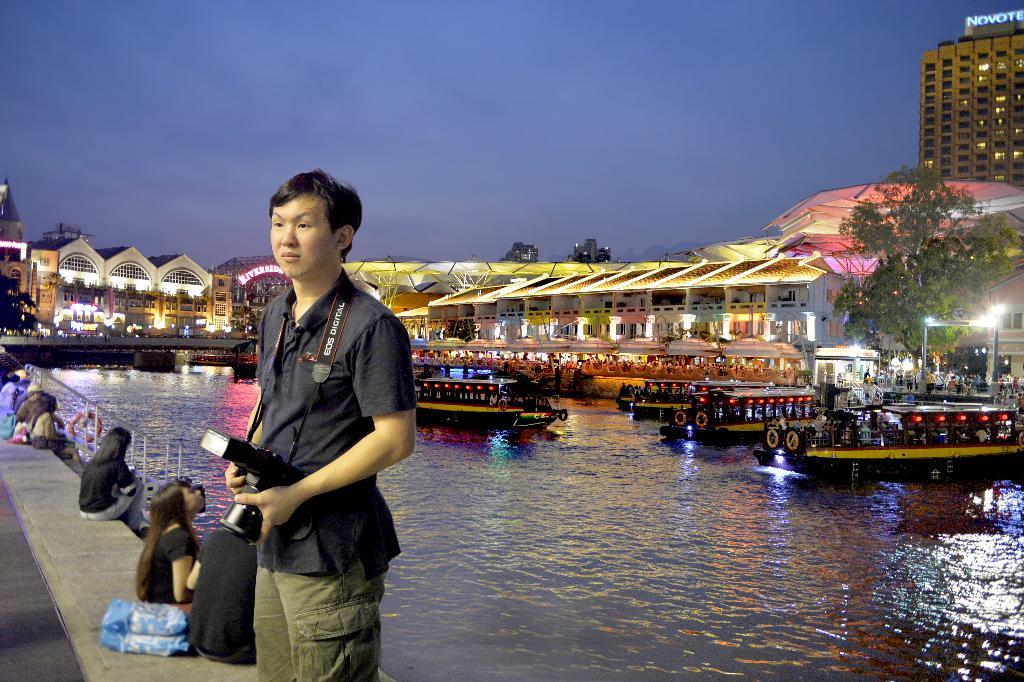What is on the water in the image? There are boats on the water in the image. What is the man wearing in the image? The man is wearing a camera in the image. What can be seen in the background of the image? There are buildings and a tree in the background of the image. What color is the sky in the image? The sky is blue in the image. What type of bell can be heard ringing in the image? There is no bell present in the image, and therefore no sound can be heard. How does the growth of the tree in the background affect the image? The image does not show the growth of the tree, only its current state. 